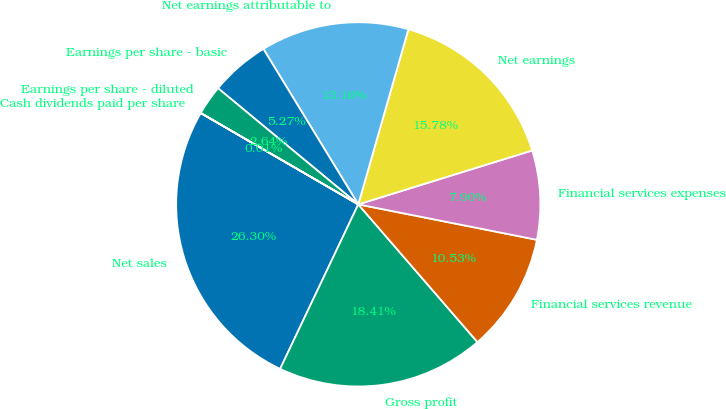Convert chart to OTSL. <chart><loc_0><loc_0><loc_500><loc_500><pie_chart><fcel>Net sales<fcel>Gross profit<fcel>Financial services revenue<fcel>Financial services expenses<fcel>Net earnings<fcel>Net earnings attributable to<fcel>Earnings per share - basic<fcel>Earnings per share - diluted<fcel>Cash dividends paid per share<nl><fcel>26.3%<fcel>18.41%<fcel>10.53%<fcel>7.9%<fcel>15.78%<fcel>13.16%<fcel>5.27%<fcel>2.64%<fcel>0.01%<nl></chart> 